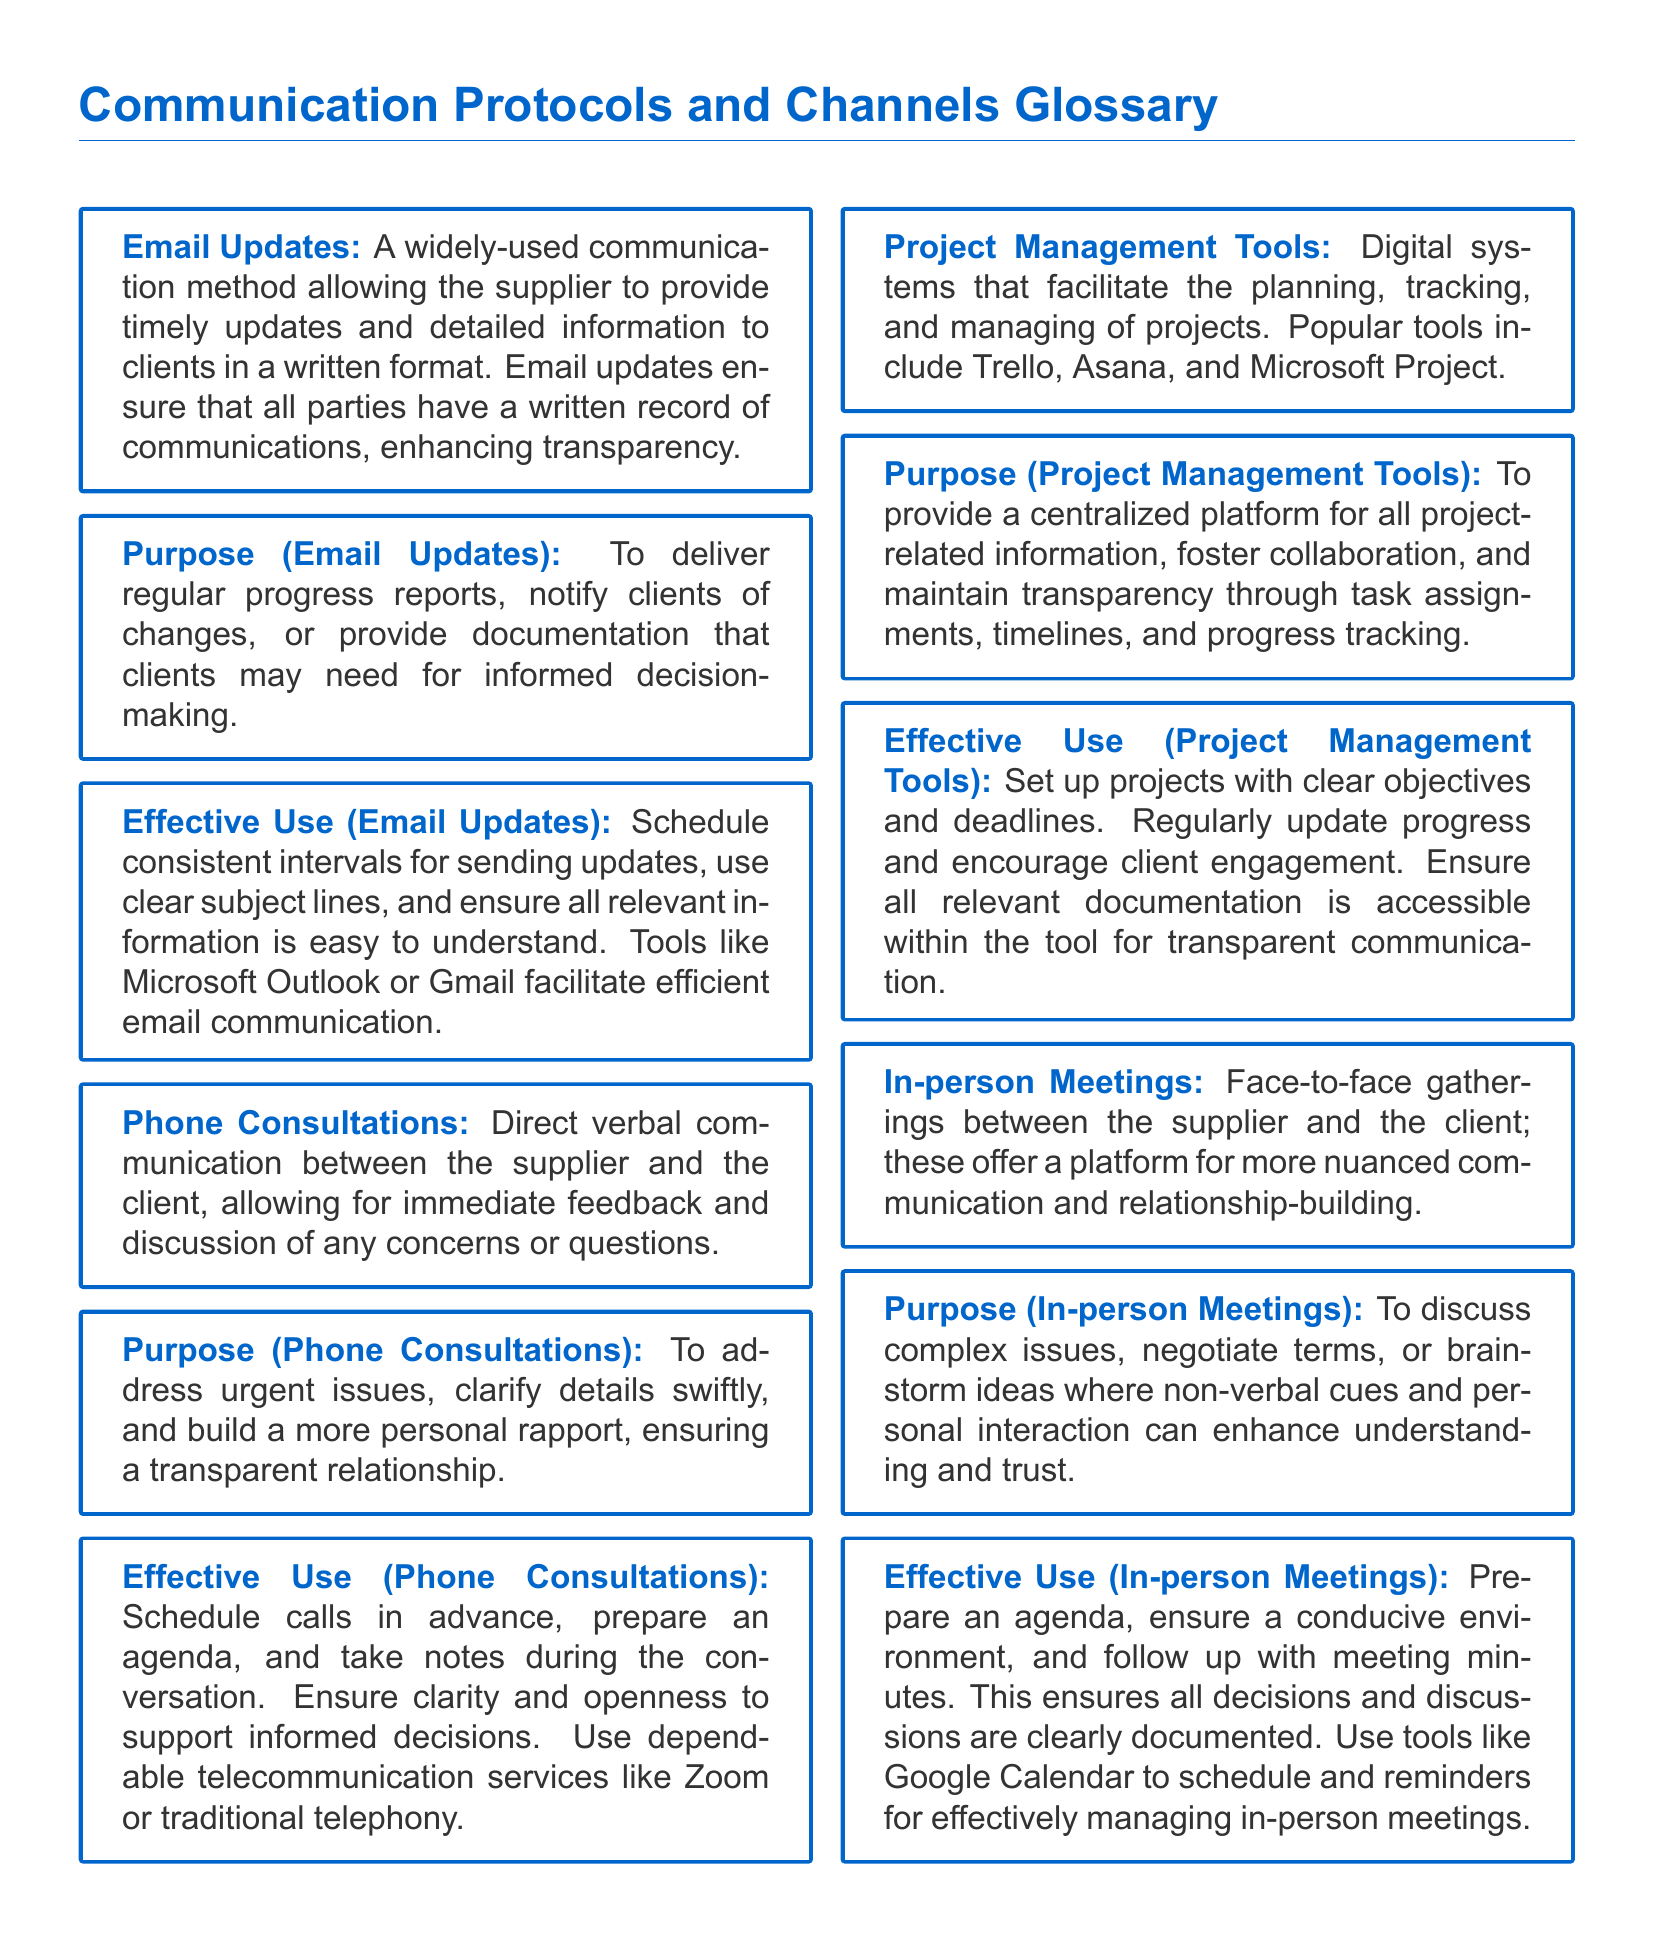what is the communication method that allows for timely updates in written format? The document states that Email Updates are a widely-used communication method for providing timely updates and detailed information to clients in a written format.
Answer: Email Updates what type of communication method is used for immediate feedback and discussion? The document describes Phone Consultations as a method for direct verbal communication allowing for immediate feedback and discussion of concerns.
Answer: Phone Consultations which tool is mentioned for facilitating digital project management? The document lists Trello, Asana, and Microsoft Project as popular digital systems for project management.
Answer: Trello, Asana, and Microsoft Project what is the primary purpose of Email Updates? Email Updates are used to deliver regular progress reports, notify clients of changes, or provide necessary documentation for informed decision-making.
Answer: Regular progress reports what is recommended for effectively managing in-person meetings? The document suggests preparing an agenda, ensuring a conducive environment, and following up with meeting minutes as effective management practices for in-person meetings.
Answer: Prepare an agenda what type of communication allows for building a more personal rapport? The document states that Phone Consultations facilitate direct communication, which helps in building a more personal rapport with clients.
Answer: Phone Consultations which method is preferred for discussing complex issues? The document indicates that In-person Meetings are the preferred method for discussing complex issues where non-verbal cues enhance understanding.
Answer: In-person Meetings what is an effective tool for scheduling meetings? The document mentions that Google Calendar is a useful tool for scheduling and reminders regarding in-person meetings.
Answer: Google Calendar what facilitates collaboration and tracking in projects? The document describes Project Management Tools as digital systems that foster collaboration and maintain transparency through task assignments and progress tracking.
Answer: Project Management Tools 